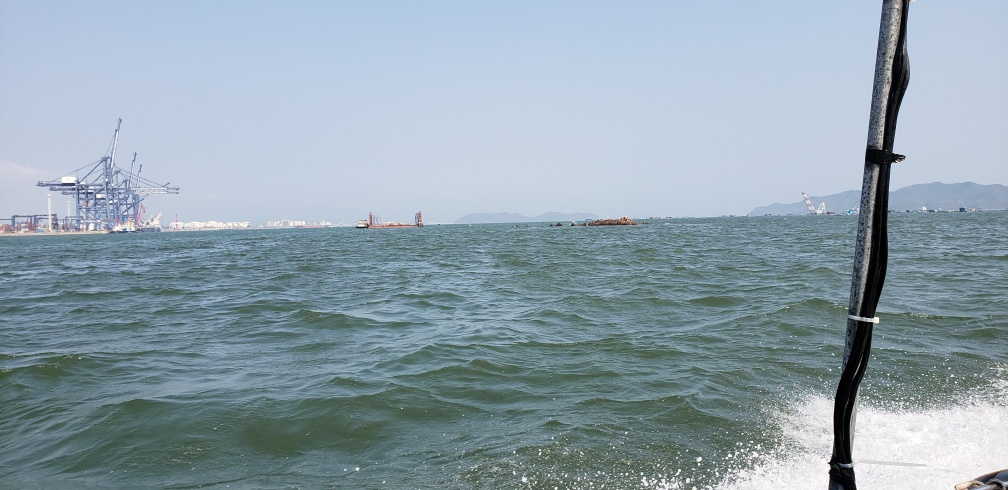What is the lighting like in this image? The image features bright, natural daylight with clear visibility. Sunlight reflects off the water's surface, indicating it is a sunny day, which contributes to the vibrant lighting of the scene. 